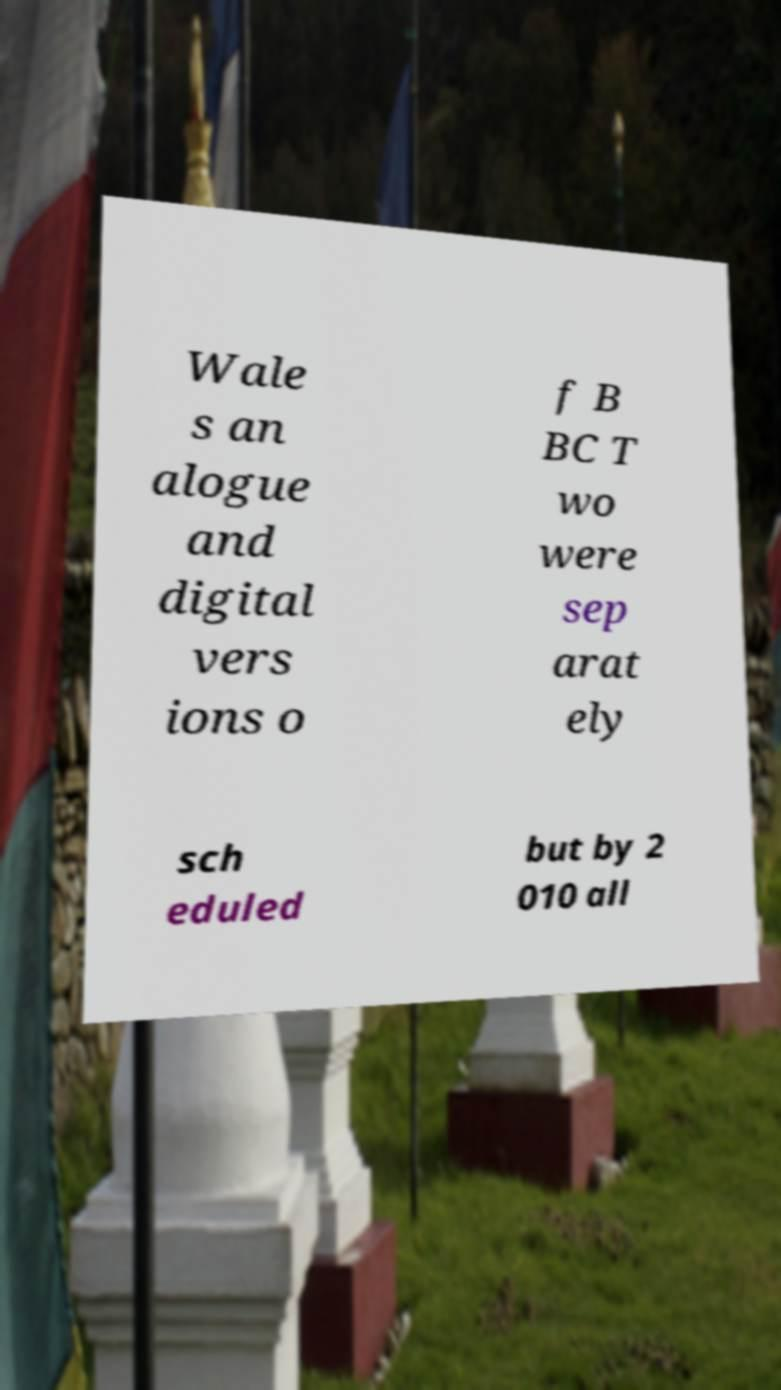There's text embedded in this image that I need extracted. Can you transcribe it verbatim? Wale s an alogue and digital vers ions o f B BC T wo were sep arat ely sch eduled but by 2 010 all 